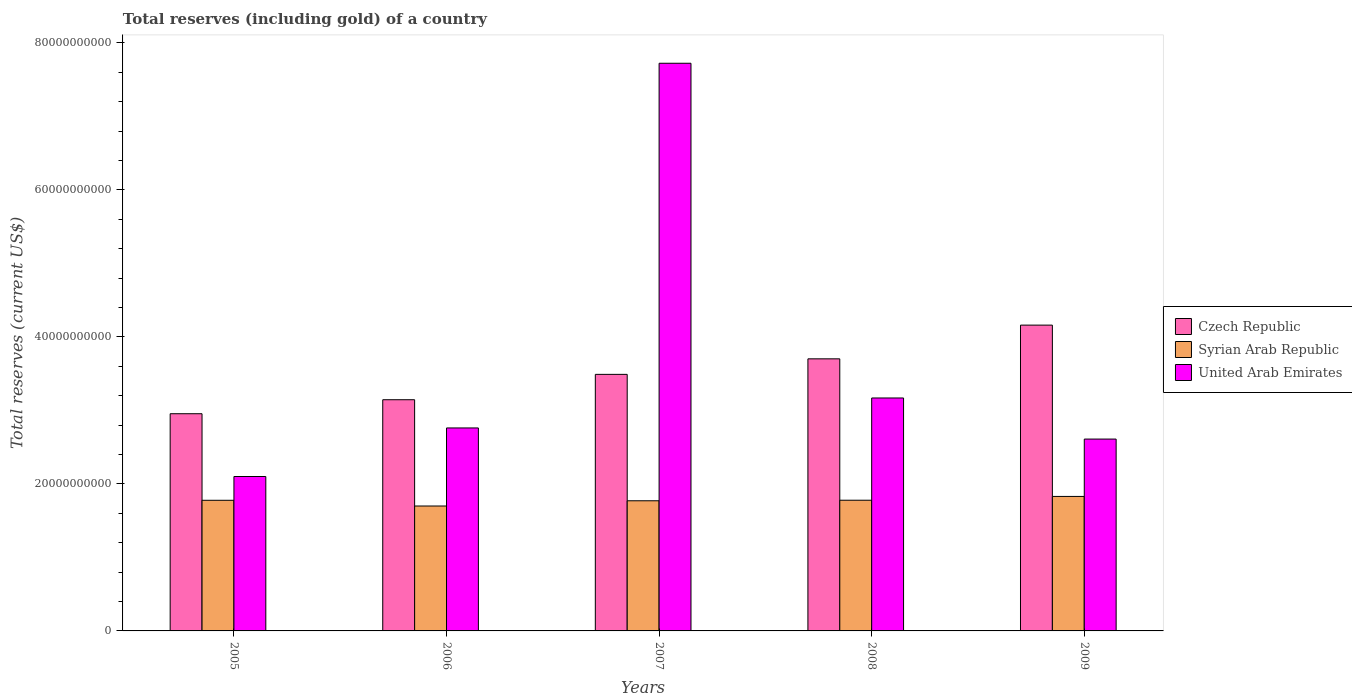How many different coloured bars are there?
Your answer should be compact. 3. How many groups of bars are there?
Ensure brevity in your answer.  5. How many bars are there on the 1st tick from the left?
Your response must be concise. 3. How many bars are there on the 1st tick from the right?
Make the answer very short. 3. In how many cases, is the number of bars for a given year not equal to the number of legend labels?
Ensure brevity in your answer.  0. What is the total reserves (including gold) in Syrian Arab Republic in 2007?
Provide a succinct answer. 1.77e+1. Across all years, what is the maximum total reserves (including gold) in Czech Republic?
Make the answer very short. 4.16e+1. Across all years, what is the minimum total reserves (including gold) in United Arab Emirates?
Your response must be concise. 2.10e+1. What is the total total reserves (including gold) in Czech Republic in the graph?
Keep it short and to the point. 1.75e+11. What is the difference between the total reserves (including gold) in Syrian Arab Republic in 2005 and that in 2006?
Provide a short and direct response. 7.77e+08. What is the difference between the total reserves (including gold) in United Arab Emirates in 2008 and the total reserves (including gold) in Syrian Arab Republic in 2005?
Provide a short and direct response. 1.39e+1. What is the average total reserves (including gold) in Syrian Arab Republic per year?
Your answer should be very brief. 1.77e+1. In the year 2005, what is the difference between the total reserves (including gold) in Syrian Arab Republic and total reserves (including gold) in Czech Republic?
Your answer should be compact. -1.18e+1. What is the ratio of the total reserves (including gold) in United Arab Emirates in 2006 to that in 2008?
Ensure brevity in your answer.  0.87. Is the total reserves (including gold) in Czech Republic in 2005 less than that in 2007?
Ensure brevity in your answer.  Yes. What is the difference between the highest and the second highest total reserves (including gold) in Syrian Arab Republic?
Give a very brief answer. 5.17e+08. What is the difference between the highest and the lowest total reserves (including gold) in United Arab Emirates?
Ensure brevity in your answer.  5.62e+1. In how many years, is the total reserves (including gold) in Czech Republic greater than the average total reserves (including gold) in Czech Republic taken over all years?
Provide a short and direct response. 2. Is the sum of the total reserves (including gold) in Czech Republic in 2006 and 2008 greater than the maximum total reserves (including gold) in United Arab Emirates across all years?
Keep it short and to the point. No. What does the 3rd bar from the left in 2005 represents?
Your response must be concise. United Arab Emirates. What does the 2nd bar from the right in 2007 represents?
Provide a succinct answer. Syrian Arab Republic. Is it the case that in every year, the sum of the total reserves (including gold) in United Arab Emirates and total reserves (including gold) in Czech Republic is greater than the total reserves (including gold) in Syrian Arab Republic?
Keep it short and to the point. Yes. How many bars are there?
Your answer should be compact. 15. How many years are there in the graph?
Provide a short and direct response. 5. What is the difference between two consecutive major ticks on the Y-axis?
Give a very brief answer. 2.00e+1. How are the legend labels stacked?
Make the answer very short. Vertical. What is the title of the graph?
Make the answer very short. Total reserves (including gold) of a country. What is the label or title of the X-axis?
Your response must be concise. Years. What is the label or title of the Y-axis?
Give a very brief answer. Total reserves (current US$). What is the Total reserves (current US$) of Czech Republic in 2005?
Make the answer very short. 2.96e+1. What is the Total reserves (current US$) of Syrian Arab Republic in 2005?
Your answer should be compact. 1.78e+1. What is the Total reserves (current US$) in United Arab Emirates in 2005?
Offer a terse response. 2.10e+1. What is the Total reserves (current US$) in Czech Republic in 2006?
Ensure brevity in your answer.  3.15e+1. What is the Total reserves (current US$) in Syrian Arab Republic in 2006?
Provide a short and direct response. 1.70e+1. What is the Total reserves (current US$) in United Arab Emirates in 2006?
Ensure brevity in your answer.  2.76e+1. What is the Total reserves (current US$) in Czech Republic in 2007?
Your response must be concise. 3.49e+1. What is the Total reserves (current US$) in Syrian Arab Republic in 2007?
Ensure brevity in your answer.  1.77e+1. What is the Total reserves (current US$) of United Arab Emirates in 2007?
Offer a very short reply. 7.72e+1. What is the Total reserves (current US$) in Czech Republic in 2008?
Your response must be concise. 3.70e+1. What is the Total reserves (current US$) in Syrian Arab Republic in 2008?
Provide a succinct answer. 1.78e+1. What is the Total reserves (current US$) of United Arab Emirates in 2008?
Provide a succinct answer. 3.17e+1. What is the Total reserves (current US$) in Czech Republic in 2009?
Provide a short and direct response. 4.16e+1. What is the Total reserves (current US$) of Syrian Arab Republic in 2009?
Your answer should be compact. 1.83e+1. What is the Total reserves (current US$) in United Arab Emirates in 2009?
Provide a succinct answer. 2.61e+1. Across all years, what is the maximum Total reserves (current US$) in Czech Republic?
Offer a terse response. 4.16e+1. Across all years, what is the maximum Total reserves (current US$) of Syrian Arab Republic?
Offer a terse response. 1.83e+1. Across all years, what is the maximum Total reserves (current US$) of United Arab Emirates?
Offer a terse response. 7.72e+1. Across all years, what is the minimum Total reserves (current US$) of Czech Republic?
Your answer should be very brief. 2.96e+1. Across all years, what is the minimum Total reserves (current US$) of Syrian Arab Republic?
Provide a short and direct response. 1.70e+1. Across all years, what is the minimum Total reserves (current US$) in United Arab Emirates?
Provide a short and direct response. 2.10e+1. What is the total Total reserves (current US$) of Czech Republic in the graph?
Offer a very short reply. 1.75e+11. What is the total Total reserves (current US$) in Syrian Arab Republic in the graph?
Offer a terse response. 8.86e+1. What is the total Total reserves (current US$) of United Arab Emirates in the graph?
Offer a terse response. 1.84e+11. What is the difference between the Total reserves (current US$) of Czech Republic in 2005 and that in 2006?
Offer a terse response. -1.90e+09. What is the difference between the Total reserves (current US$) in Syrian Arab Republic in 2005 and that in 2006?
Your response must be concise. 7.77e+08. What is the difference between the Total reserves (current US$) of United Arab Emirates in 2005 and that in 2006?
Make the answer very short. -6.61e+09. What is the difference between the Total reserves (current US$) of Czech Republic in 2005 and that in 2007?
Offer a terse response. -5.35e+09. What is the difference between the Total reserves (current US$) of Syrian Arab Republic in 2005 and that in 2007?
Keep it short and to the point. 6.67e+07. What is the difference between the Total reserves (current US$) of United Arab Emirates in 2005 and that in 2007?
Provide a succinct answer. -5.62e+1. What is the difference between the Total reserves (current US$) of Czech Republic in 2005 and that in 2008?
Ensure brevity in your answer.  -7.47e+09. What is the difference between the Total reserves (current US$) of Syrian Arab Republic in 2005 and that in 2008?
Provide a succinct answer. -9.60e+06. What is the difference between the Total reserves (current US$) of United Arab Emirates in 2005 and that in 2008?
Keep it short and to the point. -1.07e+1. What is the difference between the Total reserves (current US$) of Czech Republic in 2005 and that in 2009?
Your response must be concise. -1.21e+1. What is the difference between the Total reserves (current US$) in Syrian Arab Republic in 2005 and that in 2009?
Your response must be concise. -5.26e+08. What is the difference between the Total reserves (current US$) of United Arab Emirates in 2005 and that in 2009?
Provide a short and direct response. -5.09e+09. What is the difference between the Total reserves (current US$) of Czech Republic in 2006 and that in 2007?
Your response must be concise. -3.45e+09. What is the difference between the Total reserves (current US$) of Syrian Arab Republic in 2006 and that in 2007?
Ensure brevity in your answer.  -7.11e+08. What is the difference between the Total reserves (current US$) of United Arab Emirates in 2006 and that in 2007?
Offer a terse response. -4.96e+1. What is the difference between the Total reserves (current US$) of Czech Republic in 2006 and that in 2008?
Keep it short and to the point. -5.56e+09. What is the difference between the Total reserves (current US$) of Syrian Arab Republic in 2006 and that in 2008?
Offer a terse response. -7.87e+08. What is the difference between the Total reserves (current US$) of United Arab Emirates in 2006 and that in 2008?
Keep it short and to the point. -4.08e+09. What is the difference between the Total reserves (current US$) in Czech Republic in 2006 and that in 2009?
Your answer should be compact. -1.02e+1. What is the difference between the Total reserves (current US$) in Syrian Arab Republic in 2006 and that in 2009?
Keep it short and to the point. -1.30e+09. What is the difference between the Total reserves (current US$) in United Arab Emirates in 2006 and that in 2009?
Make the answer very short. 1.51e+09. What is the difference between the Total reserves (current US$) of Czech Republic in 2007 and that in 2008?
Your answer should be very brief. -2.11e+09. What is the difference between the Total reserves (current US$) in Syrian Arab Republic in 2007 and that in 2008?
Make the answer very short. -7.63e+07. What is the difference between the Total reserves (current US$) in United Arab Emirates in 2007 and that in 2008?
Provide a short and direct response. 4.55e+1. What is the difference between the Total reserves (current US$) of Czech Republic in 2007 and that in 2009?
Make the answer very short. -6.70e+09. What is the difference between the Total reserves (current US$) of Syrian Arab Republic in 2007 and that in 2009?
Your response must be concise. -5.93e+08. What is the difference between the Total reserves (current US$) in United Arab Emirates in 2007 and that in 2009?
Offer a terse response. 5.11e+1. What is the difference between the Total reserves (current US$) in Czech Republic in 2008 and that in 2009?
Offer a terse response. -4.59e+09. What is the difference between the Total reserves (current US$) in Syrian Arab Republic in 2008 and that in 2009?
Keep it short and to the point. -5.17e+08. What is the difference between the Total reserves (current US$) of United Arab Emirates in 2008 and that in 2009?
Ensure brevity in your answer.  5.59e+09. What is the difference between the Total reserves (current US$) of Czech Republic in 2005 and the Total reserves (current US$) of Syrian Arab Republic in 2006?
Your answer should be compact. 1.26e+1. What is the difference between the Total reserves (current US$) in Czech Republic in 2005 and the Total reserves (current US$) in United Arab Emirates in 2006?
Give a very brief answer. 1.94e+09. What is the difference between the Total reserves (current US$) of Syrian Arab Republic in 2005 and the Total reserves (current US$) of United Arab Emirates in 2006?
Your response must be concise. -9.84e+09. What is the difference between the Total reserves (current US$) of Czech Republic in 2005 and the Total reserves (current US$) of Syrian Arab Republic in 2007?
Make the answer very short. 1.18e+1. What is the difference between the Total reserves (current US$) in Czech Republic in 2005 and the Total reserves (current US$) in United Arab Emirates in 2007?
Provide a succinct answer. -4.77e+1. What is the difference between the Total reserves (current US$) in Syrian Arab Republic in 2005 and the Total reserves (current US$) in United Arab Emirates in 2007?
Your response must be concise. -5.95e+1. What is the difference between the Total reserves (current US$) of Czech Republic in 2005 and the Total reserves (current US$) of Syrian Arab Republic in 2008?
Your answer should be compact. 1.18e+1. What is the difference between the Total reserves (current US$) of Czech Republic in 2005 and the Total reserves (current US$) of United Arab Emirates in 2008?
Give a very brief answer. -2.14e+09. What is the difference between the Total reserves (current US$) in Syrian Arab Republic in 2005 and the Total reserves (current US$) in United Arab Emirates in 2008?
Ensure brevity in your answer.  -1.39e+1. What is the difference between the Total reserves (current US$) of Czech Republic in 2005 and the Total reserves (current US$) of Syrian Arab Republic in 2009?
Provide a succinct answer. 1.13e+1. What is the difference between the Total reserves (current US$) of Czech Republic in 2005 and the Total reserves (current US$) of United Arab Emirates in 2009?
Ensure brevity in your answer.  3.45e+09. What is the difference between the Total reserves (current US$) in Syrian Arab Republic in 2005 and the Total reserves (current US$) in United Arab Emirates in 2009?
Ensure brevity in your answer.  -8.33e+09. What is the difference between the Total reserves (current US$) of Czech Republic in 2006 and the Total reserves (current US$) of Syrian Arab Republic in 2007?
Provide a short and direct response. 1.37e+1. What is the difference between the Total reserves (current US$) in Czech Republic in 2006 and the Total reserves (current US$) in United Arab Emirates in 2007?
Keep it short and to the point. -4.58e+1. What is the difference between the Total reserves (current US$) in Syrian Arab Republic in 2006 and the Total reserves (current US$) in United Arab Emirates in 2007?
Keep it short and to the point. -6.02e+1. What is the difference between the Total reserves (current US$) in Czech Republic in 2006 and the Total reserves (current US$) in Syrian Arab Republic in 2008?
Offer a very short reply. 1.37e+1. What is the difference between the Total reserves (current US$) of Czech Republic in 2006 and the Total reserves (current US$) of United Arab Emirates in 2008?
Keep it short and to the point. -2.38e+08. What is the difference between the Total reserves (current US$) in Syrian Arab Republic in 2006 and the Total reserves (current US$) in United Arab Emirates in 2008?
Your answer should be very brief. -1.47e+1. What is the difference between the Total reserves (current US$) of Czech Republic in 2006 and the Total reserves (current US$) of Syrian Arab Republic in 2009?
Your answer should be very brief. 1.32e+1. What is the difference between the Total reserves (current US$) of Czech Republic in 2006 and the Total reserves (current US$) of United Arab Emirates in 2009?
Ensure brevity in your answer.  5.35e+09. What is the difference between the Total reserves (current US$) of Syrian Arab Republic in 2006 and the Total reserves (current US$) of United Arab Emirates in 2009?
Ensure brevity in your answer.  -9.11e+09. What is the difference between the Total reserves (current US$) of Czech Republic in 2007 and the Total reserves (current US$) of Syrian Arab Republic in 2008?
Make the answer very short. 1.71e+1. What is the difference between the Total reserves (current US$) in Czech Republic in 2007 and the Total reserves (current US$) in United Arab Emirates in 2008?
Offer a terse response. 3.21e+09. What is the difference between the Total reserves (current US$) of Syrian Arab Republic in 2007 and the Total reserves (current US$) of United Arab Emirates in 2008?
Your response must be concise. -1.40e+1. What is the difference between the Total reserves (current US$) of Czech Republic in 2007 and the Total reserves (current US$) of Syrian Arab Republic in 2009?
Offer a very short reply. 1.66e+1. What is the difference between the Total reserves (current US$) in Czech Republic in 2007 and the Total reserves (current US$) in United Arab Emirates in 2009?
Give a very brief answer. 8.80e+09. What is the difference between the Total reserves (current US$) in Syrian Arab Republic in 2007 and the Total reserves (current US$) in United Arab Emirates in 2009?
Keep it short and to the point. -8.40e+09. What is the difference between the Total reserves (current US$) of Czech Republic in 2008 and the Total reserves (current US$) of Syrian Arab Republic in 2009?
Offer a terse response. 1.87e+1. What is the difference between the Total reserves (current US$) of Czech Republic in 2008 and the Total reserves (current US$) of United Arab Emirates in 2009?
Your answer should be compact. 1.09e+1. What is the difference between the Total reserves (current US$) of Syrian Arab Republic in 2008 and the Total reserves (current US$) of United Arab Emirates in 2009?
Your response must be concise. -8.32e+09. What is the average Total reserves (current US$) of Czech Republic per year?
Ensure brevity in your answer.  3.49e+1. What is the average Total reserves (current US$) of Syrian Arab Republic per year?
Keep it short and to the point. 1.77e+1. What is the average Total reserves (current US$) of United Arab Emirates per year?
Make the answer very short. 3.67e+1. In the year 2005, what is the difference between the Total reserves (current US$) in Czech Republic and Total reserves (current US$) in Syrian Arab Republic?
Ensure brevity in your answer.  1.18e+1. In the year 2005, what is the difference between the Total reserves (current US$) in Czech Republic and Total reserves (current US$) in United Arab Emirates?
Ensure brevity in your answer.  8.54e+09. In the year 2005, what is the difference between the Total reserves (current US$) in Syrian Arab Republic and Total reserves (current US$) in United Arab Emirates?
Ensure brevity in your answer.  -3.24e+09. In the year 2006, what is the difference between the Total reserves (current US$) in Czech Republic and Total reserves (current US$) in Syrian Arab Republic?
Provide a short and direct response. 1.45e+1. In the year 2006, what is the difference between the Total reserves (current US$) in Czech Republic and Total reserves (current US$) in United Arab Emirates?
Give a very brief answer. 3.84e+09. In the year 2006, what is the difference between the Total reserves (current US$) of Syrian Arab Republic and Total reserves (current US$) of United Arab Emirates?
Keep it short and to the point. -1.06e+1. In the year 2007, what is the difference between the Total reserves (current US$) of Czech Republic and Total reserves (current US$) of Syrian Arab Republic?
Offer a very short reply. 1.72e+1. In the year 2007, what is the difference between the Total reserves (current US$) of Czech Republic and Total reserves (current US$) of United Arab Emirates?
Ensure brevity in your answer.  -4.23e+1. In the year 2007, what is the difference between the Total reserves (current US$) of Syrian Arab Republic and Total reserves (current US$) of United Arab Emirates?
Your answer should be very brief. -5.95e+1. In the year 2008, what is the difference between the Total reserves (current US$) of Czech Republic and Total reserves (current US$) of Syrian Arab Republic?
Offer a very short reply. 1.92e+1. In the year 2008, what is the difference between the Total reserves (current US$) of Czech Republic and Total reserves (current US$) of United Arab Emirates?
Offer a terse response. 5.33e+09. In the year 2008, what is the difference between the Total reserves (current US$) of Syrian Arab Republic and Total reserves (current US$) of United Arab Emirates?
Ensure brevity in your answer.  -1.39e+1. In the year 2009, what is the difference between the Total reserves (current US$) of Czech Republic and Total reserves (current US$) of Syrian Arab Republic?
Offer a terse response. 2.33e+1. In the year 2009, what is the difference between the Total reserves (current US$) in Czech Republic and Total reserves (current US$) in United Arab Emirates?
Offer a terse response. 1.55e+1. In the year 2009, what is the difference between the Total reserves (current US$) in Syrian Arab Republic and Total reserves (current US$) in United Arab Emirates?
Your response must be concise. -7.80e+09. What is the ratio of the Total reserves (current US$) in Czech Republic in 2005 to that in 2006?
Give a very brief answer. 0.94. What is the ratio of the Total reserves (current US$) in Syrian Arab Republic in 2005 to that in 2006?
Offer a very short reply. 1.05. What is the ratio of the Total reserves (current US$) in United Arab Emirates in 2005 to that in 2006?
Offer a very short reply. 0.76. What is the ratio of the Total reserves (current US$) of Czech Republic in 2005 to that in 2007?
Your response must be concise. 0.85. What is the ratio of the Total reserves (current US$) in Syrian Arab Republic in 2005 to that in 2007?
Ensure brevity in your answer.  1. What is the ratio of the Total reserves (current US$) in United Arab Emirates in 2005 to that in 2007?
Your response must be concise. 0.27. What is the ratio of the Total reserves (current US$) in Czech Republic in 2005 to that in 2008?
Provide a short and direct response. 0.8. What is the ratio of the Total reserves (current US$) in United Arab Emirates in 2005 to that in 2008?
Give a very brief answer. 0.66. What is the ratio of the Total reserves (current US$) of Czech Republic in 2005 to that in 2009?
Keep it short and to the point. 0.71. What is the ratio of the Total reserves (current US$) of Syrian Arab Republic in 2005 to that in 2009?
Offer a very short reply. 0.97. What is the ratio of the Total reserves (current US$) of United Arab Emirates in 2005 to that in 2009?
Offer a terse response. 0.8. What is the ratio of the Total reserves (current US$) in Czech Republic in 2006 to that in 2007?
Keep it short and to the point. 0.9. What is the ratio of the Total reserves (current US$) in Syrian Arab Republic in 2006 to that in 2007?
Give a very brief answer. 0.96. What is the ratio of the Total reserves (current US$) in United Arab Emirates in 2006 to that in 2007?
Offer a very short reply. 0.36. What is the ratio of the Total reserves (current US$) in Czech Republic in 2006 to that in 2008?
Offer a very short reply. 0.85. What is the ratio of the Total reserves (current US$) in Syrian Arab Republic in 2006 to that in 2008?
Keep it short and to the point. 0.96. What is the ratio of the Total reserves (current US$) in United Arab Emirates in 2006 to that in 2008?
Your answer should be compact. 0.87. What is the ratio of the Total reserves (current US$) of Czech Republic in 2006 to that in 2009?
Keep it short and to the point. 0.76. What is the ratio of the Total reserves (current US$) of Syrian Arab Republic in 2006 to that in 2009?
Offer a terse response. 0.93. What is the ratio of the Total reserves (current US$) of United Arab Emirates in 2006 to that in 2009?
Provide a succinct answer. 1.06. What is the ratio of the Total reserves (current US$) of Czech Republic in 2007 to that in 2008?
Offer a terse response. 0.94. What is the ratio of the Total reserves (current US$) of United Arab Emirates in 2007 to that in 2008?
Offer a very short reply. 2.44. What is the ratio of the Total reserves (current US$) in Czech Republic in 2007 to that in 2009?
Provide a succinct answer. 0.84. What is the ratio of the Total reserves (current US$) in Syrian Arab Republic in 2007 to that in 2009?
Give a very brief answer. 0.97. What is the ratio of the Total reserves (current US$) of United Arab Emirates in 2007 to that in 2009?
Keep it short and to the point. 2.96. What is the ratio of the Total reserves (current US$) in Czech Republic in 2008 to that in 2009?
Make the answer very short. 0.89. What is the ratio of the Total reserves (current US$) of Syrian Arab Republic in 2008 to that in 2009?
Your answer should be very brief. 0.97. What is the ratio of the Total reserves (current US$) in United Arab Emirates in 2008 to that in 2009?
Keep it short and to the point. 1.21. What is the difference between the highest and the second highest Total reserves (current US$) in Czech Republic?
Keep it short and to the point. 4.59e+09. What is the difference between the highest and the second highest Total reserves (current US$) in Syrian Arab Republic?
Provide a succinct answer. 5.17e+08. What is the difference between the highest and the second highest Total reserves (current US$) in United Arab Emirates?
Your response must be concise. 4.55e+1. What is the difference between the highest and the lowest Total reserves (current US$) in Czech Republic?
Ensure brevity in your answer.  1.21e+1. What is the difference between the highest and the lowest Total reserves (current US$) in Syrian Arab Republic?
Ensure brevity in your answer.  1.30e+09. What is the difference between the highest and the lowest Total reserves (current US$) in United Arab Emirates?
Ensure brevity in your answer.  5.62e+1. 